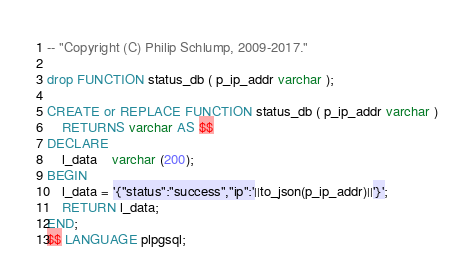<code> <loc_0><loc_0><loc_500><loc_500><_SQL_>
-- "Copyright (C) Philip Schlump, 2009-2017." 

drop FUNCTION status_db ( p_ip_addr varchar );

CREATE or REPLACE FUNCTION status_db ( p_ip_addr varchar )
	RETURNS varchar AS $$
DECLARE
	l_data	varchar (200);
BEGIN
	l_data = '{"status":"success","ip":'||to_json(p_ip_addr)||'}';
	RETURN l_data;
END;
$$ LANGUAGE plpgsql;

</code> 